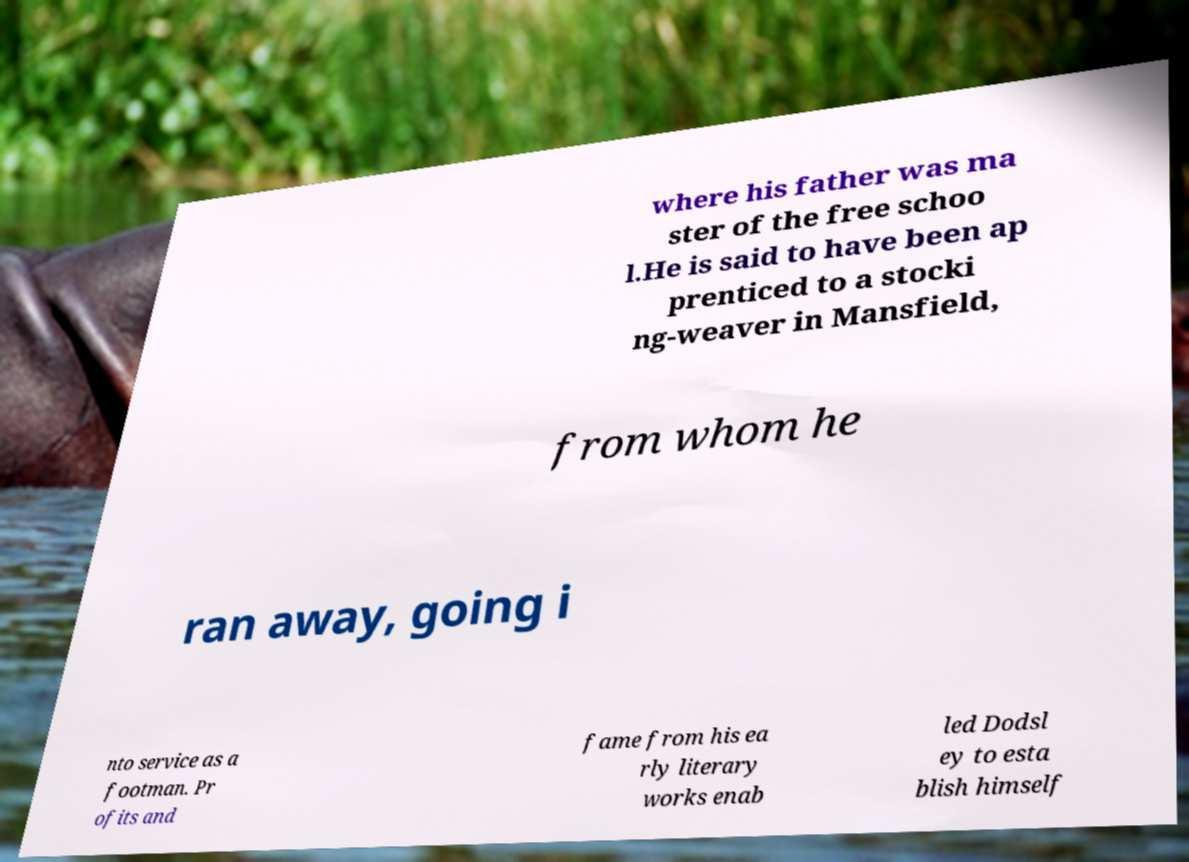Can you accurately transcribe the text from the provided image for me? where his father was ma ster of the free schoo l.He is said to have been ap prenticed to a stocki ng-weaver in Mansfield, from whom he ran away, going i nto service as a footman. Pr ofits and fame from his ea rly literary works enab led Dodsl ey to esta blish himself 